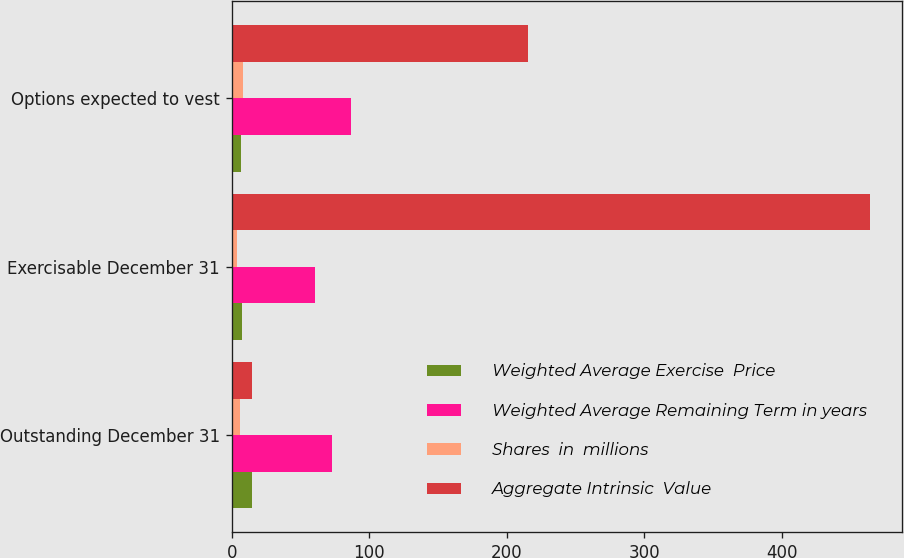Convert chart. <chart><loc_0><loc_0><loc_500><loc_500><stacked_bar_chart><ecel><fcel>Outstanding December 31<fcel>Exercisable December 31<fcel>Options expected to vest<nl><fcel>Weighted Average Exercise  Price<fcel>14.9<fcel>7.8<fcel>6.5<nl><fcel>Weighted Average Remaining Term in years<fcel>73.14<fcel>60.3<fcel>86.75<nl><fcel>Shares  in  millions<fcel>5.9<fcel>4<fcel>7.9<nl><fcel>Aggregate Intrinsic  Value<fcel>14.9<fcel>464.4<fcel>215.1<nl></chart> 